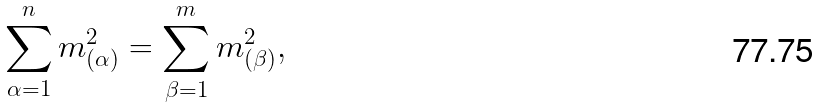<formula> <loc_0><loc_0><loc_500><loc_500>\sum _ { \alpha = 1 } ^ { n } m _ { ( \alpha ) } ^ { 2 } = \sum _ { \beta = 1 } ^ { m } m _ { ( \beta ) } ^ { 2 } ,</formula> 